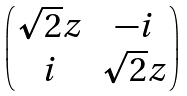Convert formula to latex. <formula><loc_0><loc_0><loc_500><loc_500>\begin{pmatrix} \sqrt { 2 } z & - i \\ i & \sqrt { 2 } z \end{pmatrix}</formula> 